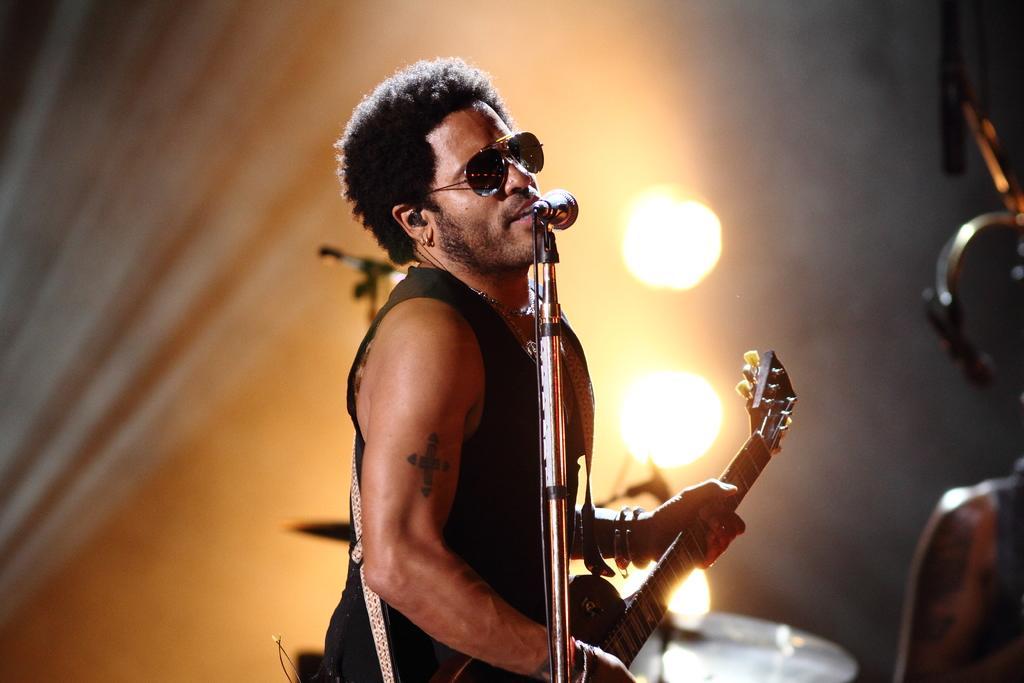How would you summarize this image in a sentence or two? In this image we can see a man standing and playing guitar. There is a mic in front of him through which he is singing. In the background we can see show lights. 